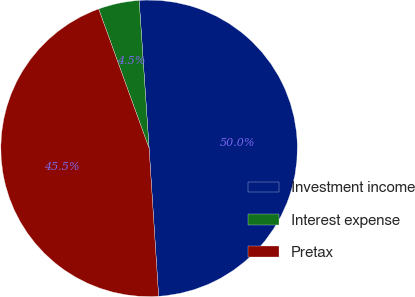Convert chart. <chart><loc_0><loc_0><loc_500><loc_500><pie_chart><fcel>Investment income<fcel>Interest expense<fcel>Pretax<nl><fcel>50.04%<fcel>4.46%<fcel>45.49%<nl></chart> 